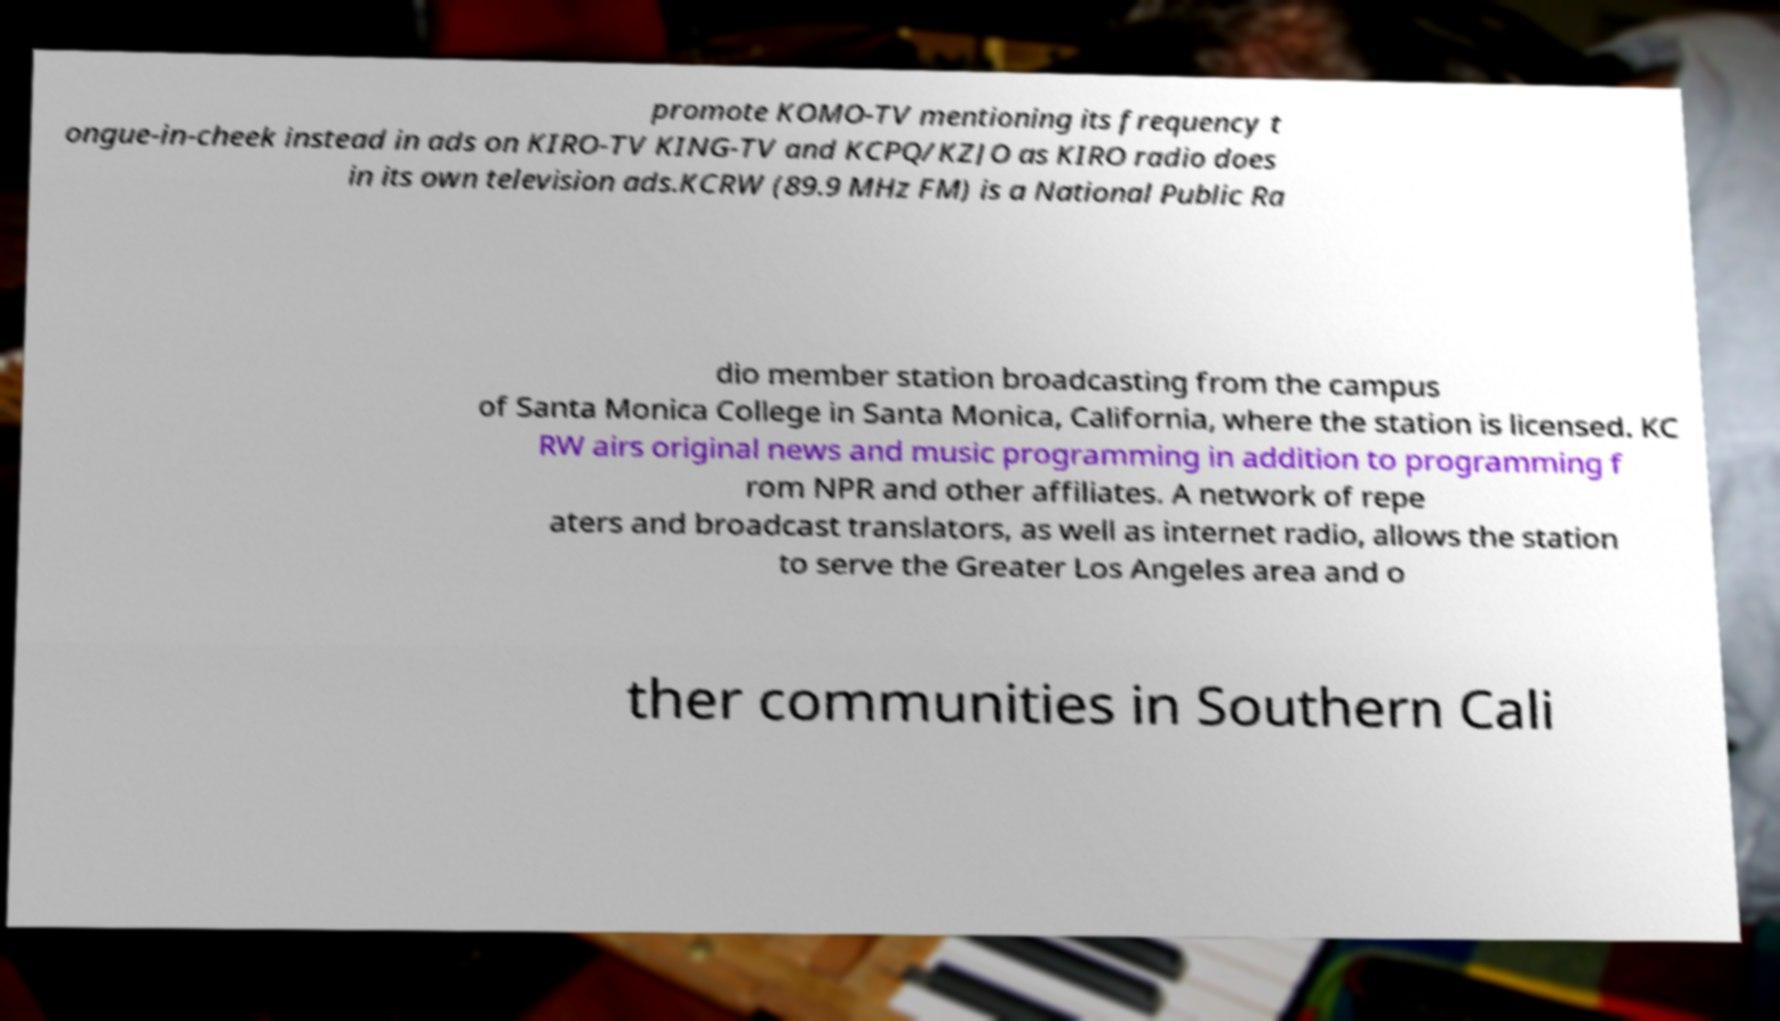Could you extract and type out the text from this image? promote KOMO-TV mentioning its frequency t ongue-in-cheek instead in ads on KIRO-TV KING-TV and KCPQ/KZJO as KIRO radio does in its own television ads.KCRW (89.9 MHz FM) is a National Public Ra dio member station broadcasting from the campus of Santa Monica College in Santa Monica, California, where the station is licensed. KC RW airs original news and music programming in addition to programming f rom NPR and other affiliates. A network of repe aters and broadcast translators, as well as internet radio, allows the station to serve the Greater Los Angeles area and o ther communities in Southern Cali 